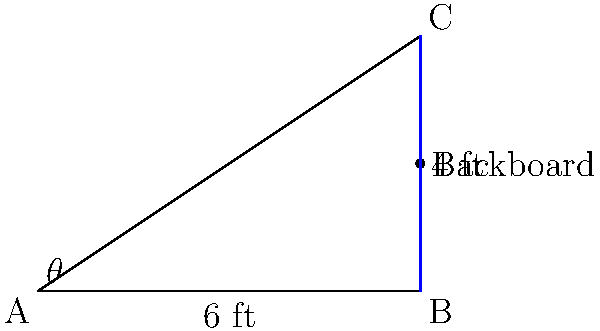As a point guard adapting to the team's new dynamics, you're practicing bank shots. The backboard is 6 feet away from where you're standing, and its height is 4 feet above your release point. What is the optimal angle $\theta$ (in degrees) for the bank shot, assuming the ball travels in a straight line and follows the laws of reflection? To find the optimal angle for the bank shot, we need to use the properties of right triangles and the law of reflection. Here's how we can solve this step-by-step:

1) First, we identify the right triangle formed by your position (A), the point where the ball hits the backboard (C), and the base of the backboard (B).

2) We know the base of the triangle (AB) is 6 feet, and the height (BC) is 4 feet.

3) To find the optimal angle, we need to ensure that the angle of incidence equals the angle of reflection. This occurs when the ball hits the backboard at its midpoint.

4) The midpoint of the backboard is at 2 feet (half of 4 feet).

5) Now we have a right triangle where:
   - The base (adjacent to our angle $\theta$) is 6 feet
   - The height (opposite to our angle $\theta$) is 2 feet

6) We can find $\theta$ using the arctangent function:

   $$\theta = \arctan(\frac{\text{opposite}}{\text{adjacent}}) = \arctan(\frac{2}{6})$$

7) Simplify the fraction:

   $$\theta = \arctan(\frac{1}{3})$$

8) Calculate this value and convert to degrees:

   $$\theta \approx 18.43^\circ$$

Therefore, the optimal angle for the bank shot is approximately 18.43 degrees.
Answer: $18.43^\circ$ 